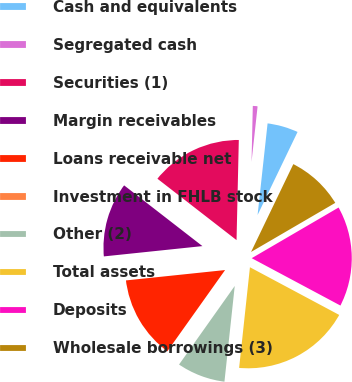<chart> <loc_0><loc_0><loc_500><loc_500><pie_chart><fcel>Cash and equivalents<fcel>Segregated cash<fcel>Securities (1)<fcel>Margin receivables<fcel>Loans receivable net<fcel>Investment in FHLB stock<fcel>Other (2)<fcel>Total assets<fcel>Deposits<fcel>Wholesale borrowings (3)<nl><fcel>5.41%<fcel>1.37%<fcel>14.86%<fcel>12.16%<fcel>13.51%<fcel>0.02%<fcel>8.11%<fcel>18.9%<fcel>16.21%<fcel>9.46%<nl></chart> 